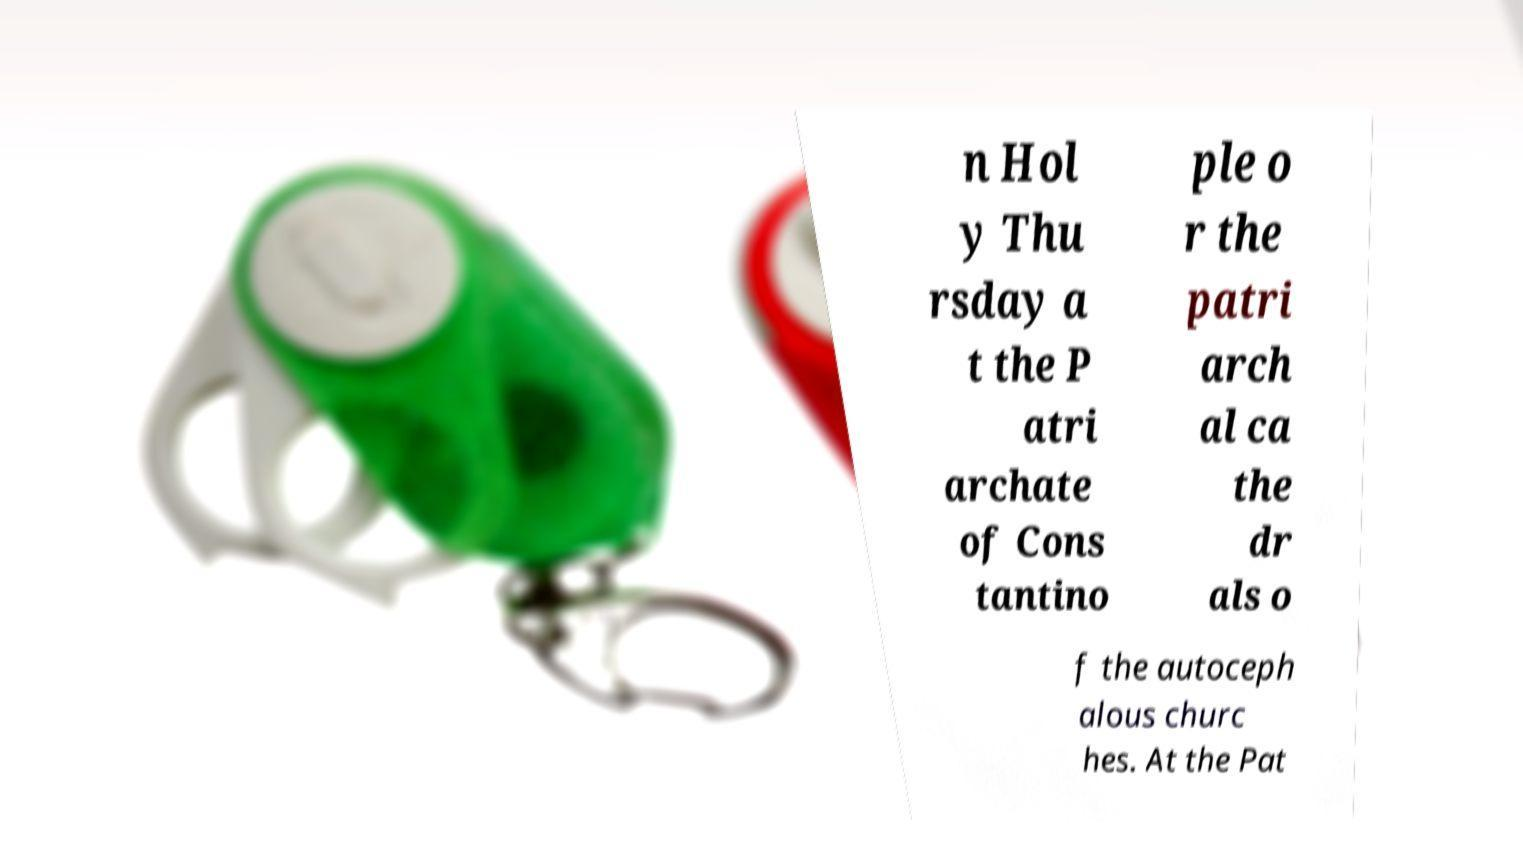Please identify and transcribe the text found in this image. n Hol y Thu rsday a t the P atri archate of Cons tantino ple o r the patri arch al ca the dr als o f the autoceph alous churc hes. At the Pat 